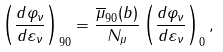<formula> <loc_0><loc_0><loc_500><loc_500>\left ( \frac { d \varphi _ { \nu } } { d \varepsilon _ { \nu } } \right ) _ { 9 0 } = \frac { \overline { \mu } _ { 9 0 } ( b ) } { N _ { \mu } } \left ( \frac { d \varphi _ { \nu } } { d \varepsilon _ { \nu } } \right ) _ { 0 } ,</formula> 